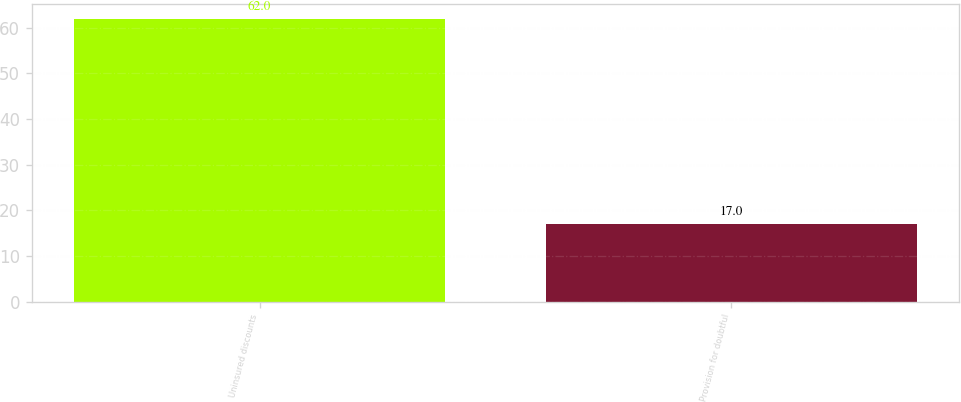<chart> <loc_0><loc_0><loc_500><loc_500><bar_chart><fcel>Uninsured discounts<fcel>Provision for doubtful<nl><fcel>62<fcel>17<nl></chart> 